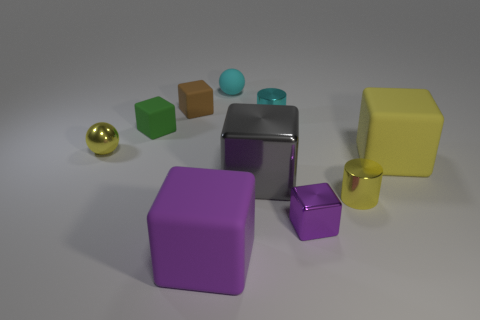Are there any purple matte things?
Ensure brevity in your answer.  Yes. Are there an equal number of yellow rubber objects that are in front of the yellow metal cylinder and brown matte objects?
Offer a terse response. No. How many other things are the same shape as the big gray object?
Offer a terse response. 5. The small purple shiny thing is what shape?
Give a very brief answer. Cube. Do the brown object and the big purple object have the same material?
Give a very brief answer. Yes. Is the number of metal spheres that are right of the gray thing the same as the number of purple matte things behind the small yellow shiny ball?
Provide a succinct answer. Yes. There is a small sphere left of the large thing on the left side of the tiny cyan rubber sphere; is there a gray object left of it?
Keep it short and to the point. No. Do the metal ball and the green block have the same size?
Ensure brevity in your answer.  Yes. There is a matte cube that is right of the yellow metal thing that is right of the small yellow thing behind the big metallic block; what is its color?
Make the answer very short. Yellow. What number of tiny matte objects are the same color as the large metal block?
Keep it short and to the point. 0. 